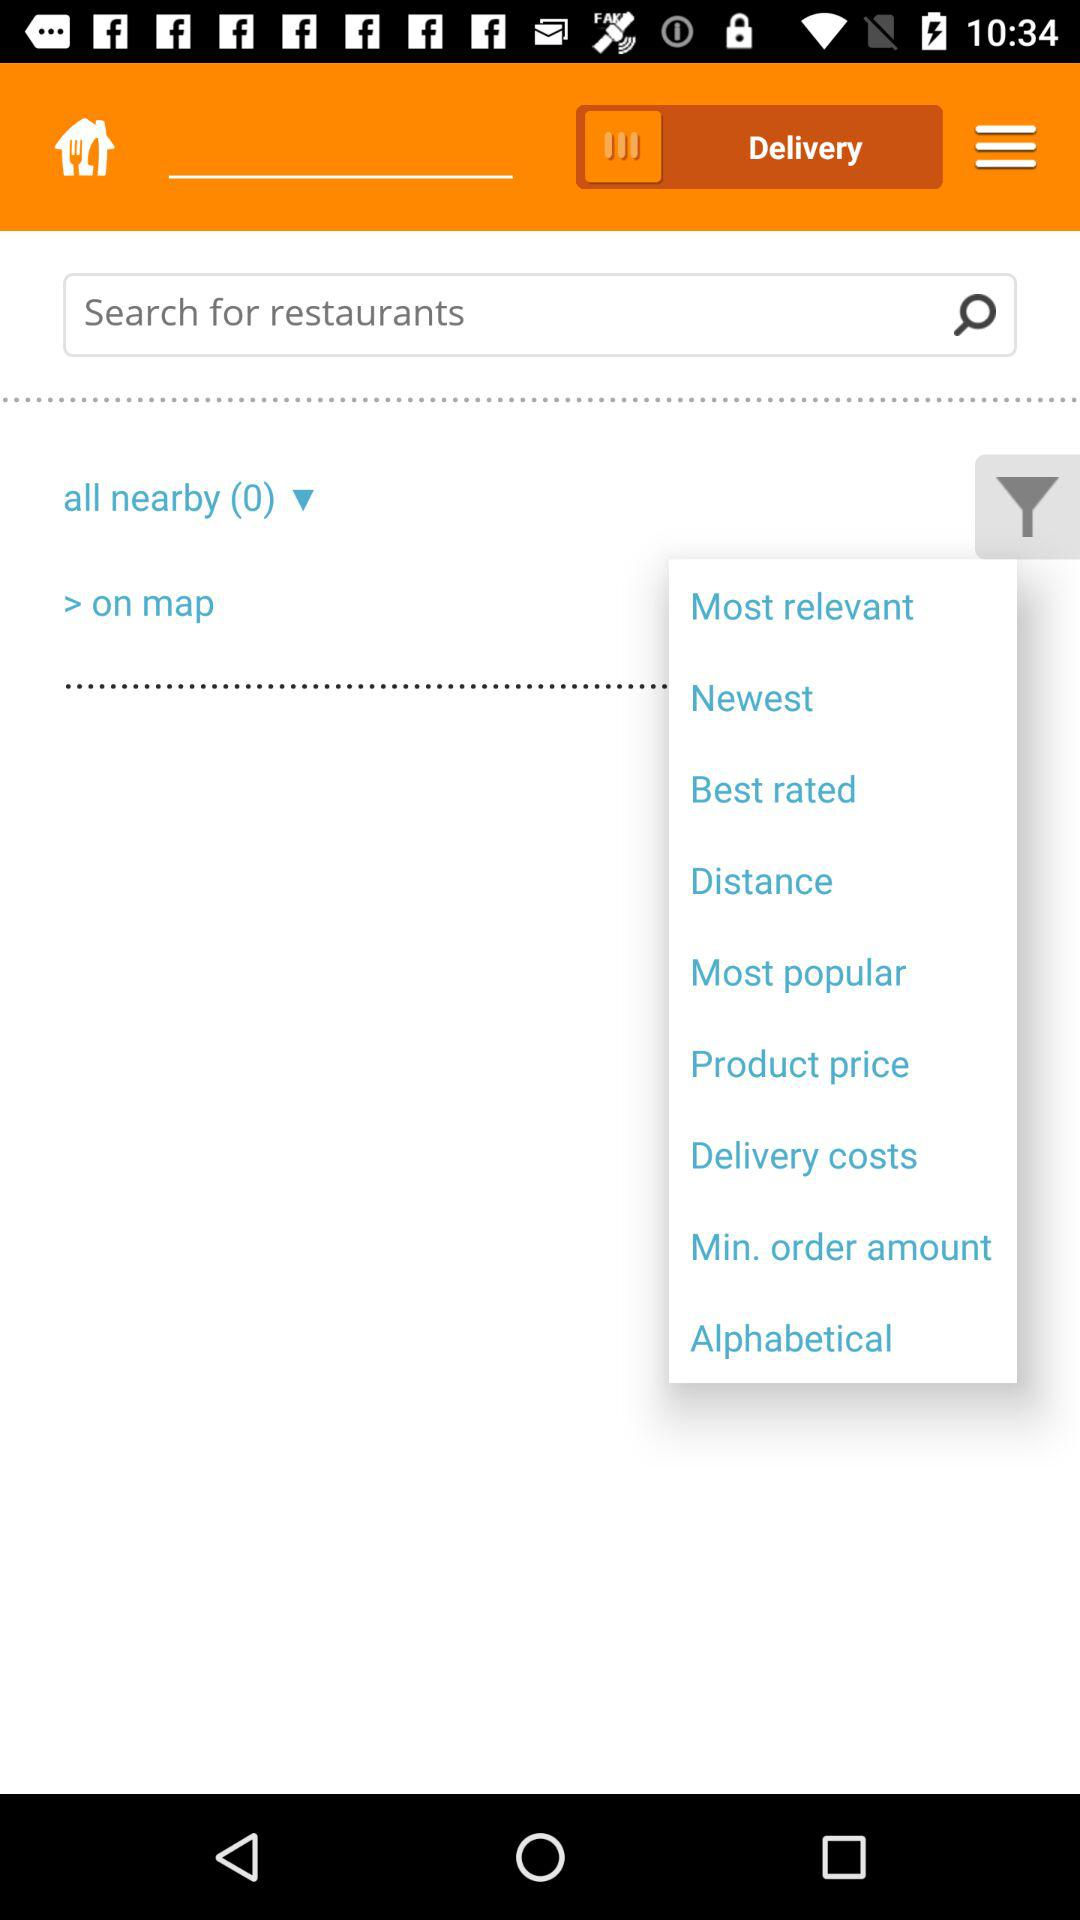What's the total number of all nearby restaurants? The total number of all nearby restaurants is 0. 